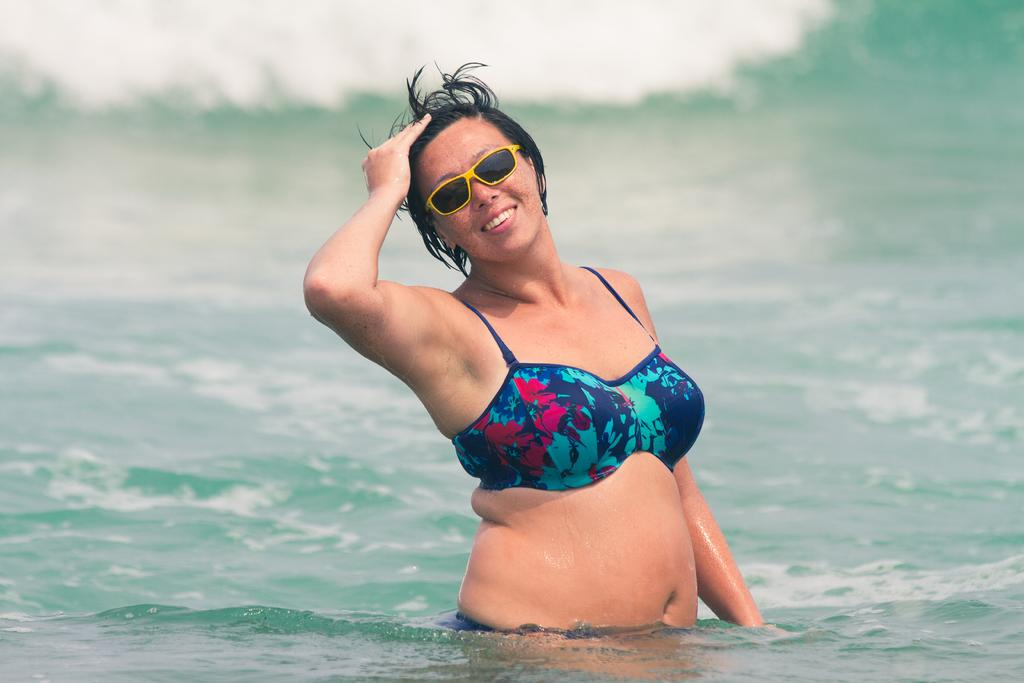Who is present in the image? There is a woman in the image. What is the woman doing in the image? The woman is smiling in the image. What accessory is the woman wearing? The woman is wearing goggles in the image. What can be seen at the bottom of the image? There is water visible at the bottom of the image. Where is the faucet located in the image? There is no faucet present in the image. Can you see any steam coming from the water in the image? There is no steam visible in the image. 